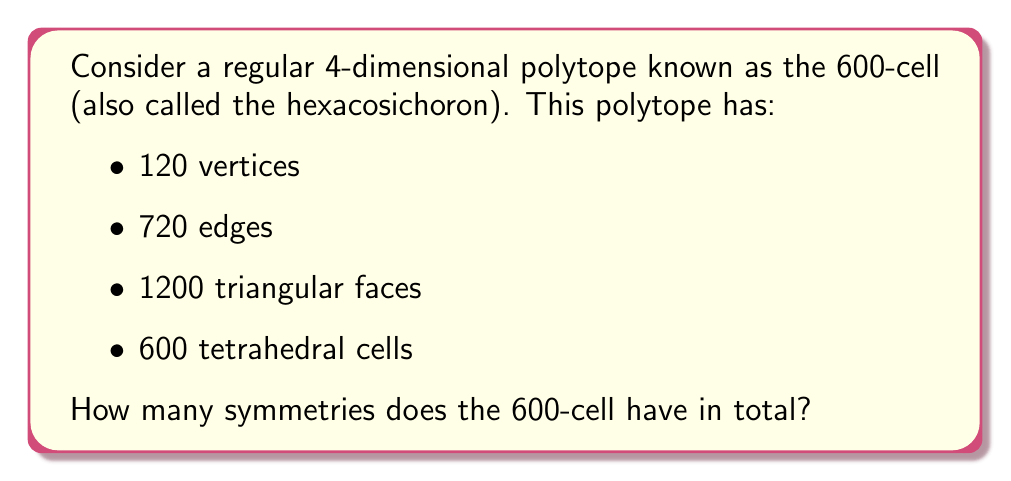Give your solution to this math problem. To determine the number of symmetries of the 600-cell, we need to consider its structure and properties:

1) The 600-cell is a regular 4-dimensional polytope, which means it has the highest degree of symmetry possible for a 4D object.

2) The symmetry group of the 600-cell is isomorphic to the H4 Coxeter group, which is a finite reflection group in 4 dimensions.

3) To calculate the order of this symmetry group, we can use the following facts:

   a) The 600-cell has 120 vertices.
   b) Any symmetry of the 600-cell can be uniquely determined by its action on the vertices.
   c) The symmetry group acts transitively on the vertices, meaning any vertex can be mapped to any other vertex.

4) For the first vertex, we have 120 choices (all vertices).

5) After fixing the first vertex, we need to determine where the second vertex goes. There are 12 edges connected to each vertex in the 600-cell, so we have 12 choices for the second vertex.

6) For the third vertex, we have 5 choices, as there are 5 vertices adjacent to both the first and second vertices we've already placed.

7) For the fourth vertex, we have 2 choices, as there are 2 vertices adjacent to all three previously placed vertices.

8) After placing these 4 vertices, the position of all other vertices is determined due to the rigid structure of the 600-cell.

9) Therefore, the total number of symmetries is:

   $$120 \times 12 \times 5 \times 2 = 14,400$$

This number can also be expressed as $2^6 \times 3^2 \times 5^2$.
Answer: The 600-cell has 14,400 symmetries. 